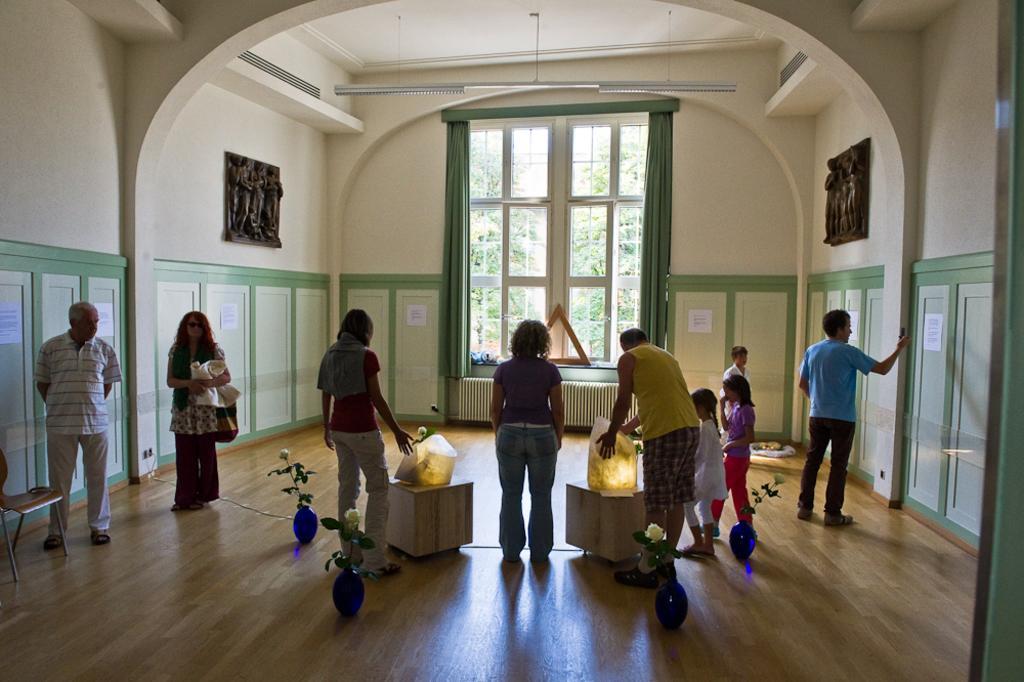Please provide a concise description of this image. In this image we can see the inside view of a room, there are three women standing, there are three men standing, there is a boy standing, there is a girl standing, there is a girl walking, there is a woman holding an object, the men are holding an object, there is a chair towards the left of the image, there is a wall, there are objects on the wall, there are papers on the wall, there is text on the papers, there are windows, there are curtains, there are plants, there are lights, there is roof towards the top of the image, there is a wooden floor towards the bottom of the image, there are objects on the wooden floor. 